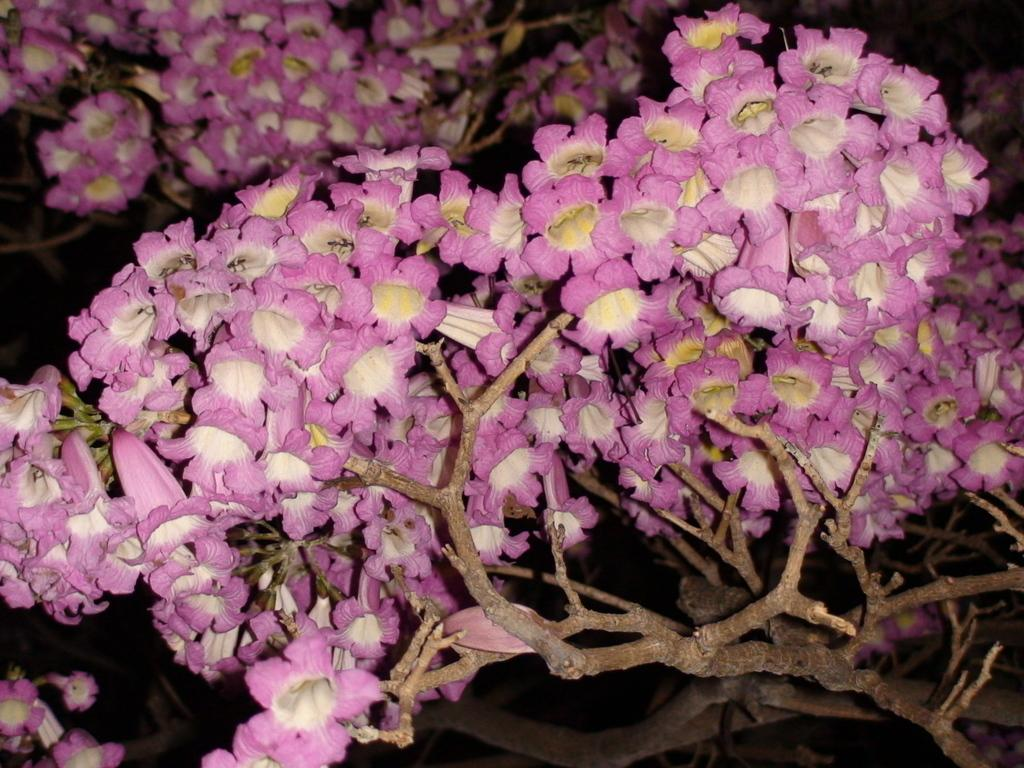What is depicted on the branches in the image? There are flowers on the branches in the image. What can be observed about the background of the image? The background of the image is dark. How many friends are sitting on the committee in the image? There are no friends or committees present in the image; it features branches with flowers against a dark background. What type of jar is visible on the branches in the image? There is no jar present on the branches in the image; it only features flowers. 